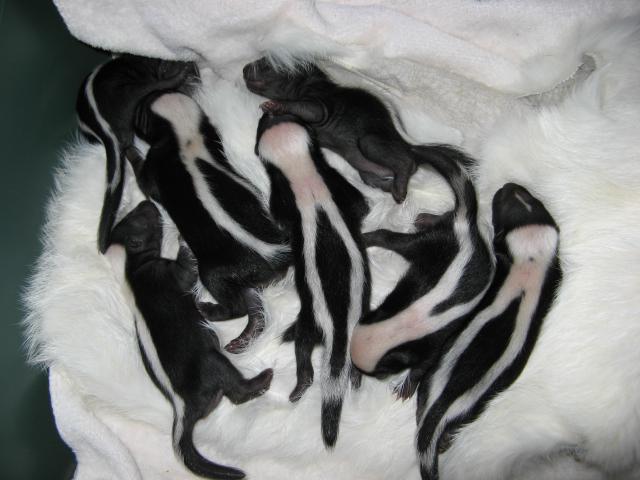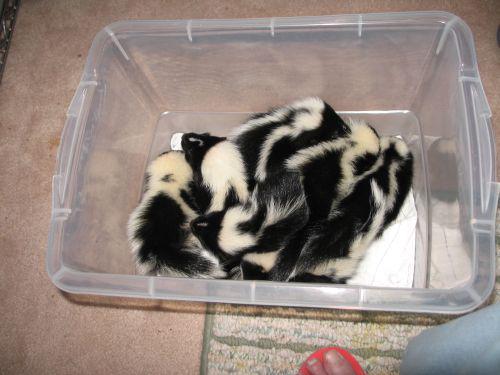The first image is the image on the left, the second image is the image on the right. Examine the images to the left and right. Is the description "All the skunks are in containers." accurate? Answer yes or no. No. 